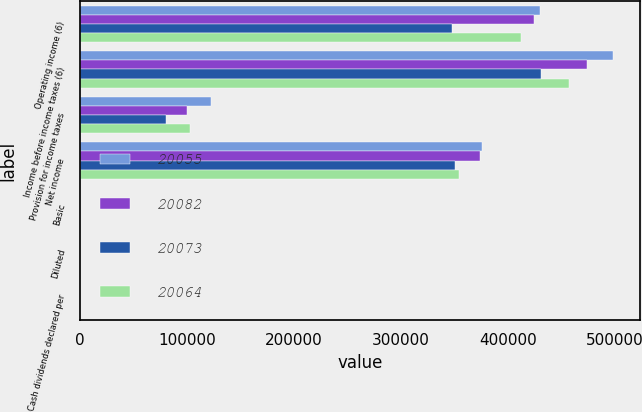Convert chart. <chart><loc_0><loc_0><loc_500><loc_500><stacked_bar_chart><ecel><fcel>Operating income (6)<fcel>Income before income taxes (6)<fcel>Provision for income taxes<fcel>Net income<fcel>Basic<fcel>Diluted<fcel>Cash dividends declared per<nl><fcel>20055<fcel>429518<fcel>498184<fcel>122544<fcel>375640<fcel>1.36<fcel>1.36<fcel>0.56<nl><fcel>20082<fcel>424194<fcel>474094<fcel>100047<fcel>374047<fcel>1.27<fcel>1.25<fcel>0.48<nl><fcel>20073<fcel>347767<fcel>431146<fcel>80474<fcel>350672<fcel>1.04<fcel>1.02<fcel>0.36<nl><fcel>20064<fcel>412062<fcel>456602<fcel>102453<fcel>354149<fcel>1.01<fcel>1<fcel>0.28<nl></chart> 